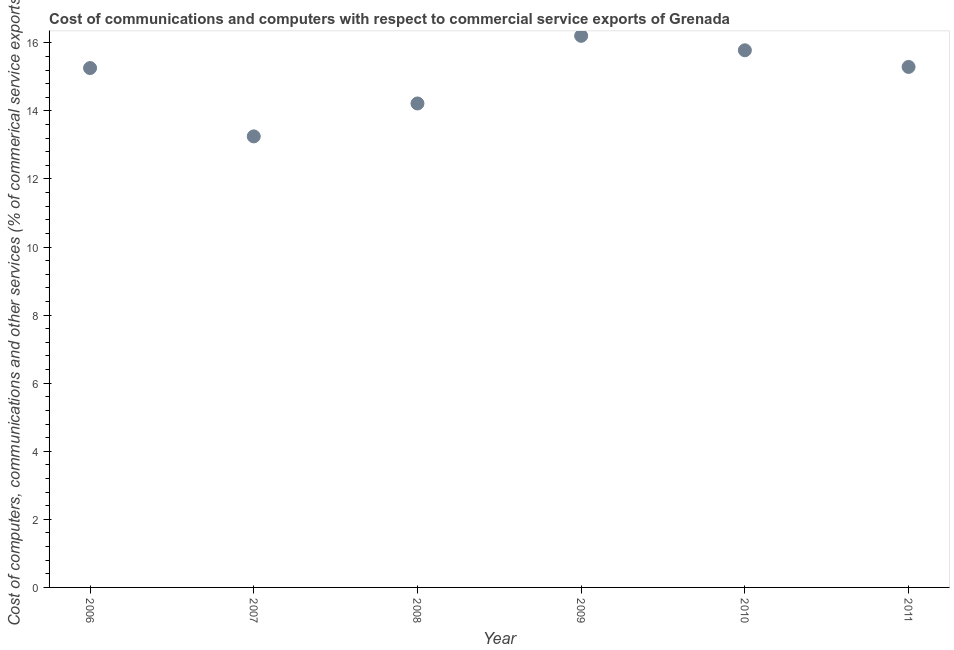What is the  computer and other services in 2006?
Ensure brevity in your answer.  15.26. Across all years, what is the maximum cost of communications?
Give a very brief answer. 16.2. Across all years, what is the minimum cost of communications?
Keep it short and to the point. 13.25. What is the sum of the  computer and other services?
Provide a succinct answer. 90. What is the difference between the  computer and other services in 2007 and 2008?
Ensure brevity in your answer.  -0.97. What is the average cost of communications per year?
Provide a succinct answer. 15. What is the median  computer and other services?
Give a very brief answer. 15.27. In how many years, is the cost of communications greater than 8.8 %?
Offer a very short reply. 6. Do a majority of the years between 2007 and 2011 (inclusive) have cost of communications greater than 10.8 %?
Ensure brevity in your answer.  Yes. What is the ratio of the  computer and other services in 2006 to that in 2009?
Offer a very short reply. 0.94. Is the cost of communications in 2006 less than that in 2009?
Your answer should be very brief. Yes. Is the difference between the cost of communications in 2009 and 2010 greater than the difference between any two years?
Make the answer very short. No. What is the difference between the highest and the second highest cost of communications?
Your response must be concise. 0.42. What is the difference between the highest and the lowest cost of communications?
Make the answer very short. 2.95. Does the  computer and other services monotonically increase over the years?
Your response must be concise. No. How many dotlines are there?
Offer a very short reply. 1. What is the difference between two consecutive major ticks on the Y-axis?
Offer a terse response. 2. Are the values on the major ticks of Y-axis written in scientific E-notation?
Provide a succinct answer. No. Does the graph contain any zero values?
Ensure brevity in your answer.  No. What is the title of the graph?
Your response must be concise. Cost of communications and computers with respect to commercial service exports of Grenada. What is the label or title of the Y-axis?
Your answer should be very brief. Cost of computers, communications and other services (% of commerical service exports). What is the Cost of computers, communications and other services (% of commerical service exports) in 2006?
Your answer should be very brief. 15.26. What is the Cost of computers, communications and other services (% of commerical service exports) in 2007?
Offer a very short reply. 13.25. What is the Cost of computers, communications and other services (% of commerical service exports) in 2008?
Make the answer very short. 14.22. What is the Cost of computers, communications and other services (% of commerical service exports) in 2009?
Give a very brief answer. 16.2. What is the Cost of computers, communications and other services (% of commerical service exports) in 2010?
Your answer should be very brief. 15.78. What is the Cost of computers, communications and other services (% of commerical service exports) in 2011?
Ensure brevity in your answer.  15.29. What is the difference between the Cost of computers, communications and other services (% of commerical service exports) in 2006 and 2007?
Provide a short and direct response. 2.01. What is the difference between the Cost of computers, communications and other services (% of commerical service exports) in 2006 and 2008?
Your answer should be compact. 1.04. What is the difference between the Cost of computers, communications and other services (% of commerical service exports) in 2006 and 2009?
Keep it short and to the point. -0.95. What is the difference between the Cost of computers, communications and other services (% of commerical service exports) in 2006 and 2010?
Provide a succinct answer. -0.52. What is the difference between the Cost of computers, communications and other services (% of commerical service exports) in 2006 and 2011?
Give a very brief answer. -0.03. What is the difference between the Cost of computers, communications and other services (% of commerical service exports) in 2007 and 2008?
Keep it short and to the point. -0.97. What is the difference between the Cost of computers, communications and other services (% of commerical service exports) in 2007 and 2009?
Keep it short and to the point. -2.95. What is the difference between the Cost of computers, communications and other services (% of commerical service exports) in 2007 and 2010?
Your answer should be compact. -2.53. What is the difference between the Cost of computers, communications and other services (% of commerical service exports) in 2007 and 2011?
Your response must be concise. -2.04. What is the difference between the Cost of computers, communications and other services (% of commerical service exports) in 2008 and 2009?
Your answer should be very brief. -1.99. What is the difference between the Cost of computers, communications and other services (% of commerical service exports) in 2008 and 2010?
Offer a terse response. -1.56. What is the difference between the Cost of computers, communications and other services (% of commerical service exports) in 2008 and 2011?
Ensure brevity in your answer.  -1.07. What is the difference between the Cost of computers, communications and other services (% of commerical service exports) in 2009 and 2010?
Your answer should be compact. 0.42. What is the difference between the Cost of computers, communications and other services (% of commerical service exports) in 2009 and 2011?
Give a very brief answer. 0.91. What is the difference between the Cost of computers, communications and other services (% of commerical service exports) in 2010 and 2011?
Provide a short and direct response. 0.49. What is the ratio of the Cost of computers, communications and other services (% of commerical service exports) in 2006 to that in 2007?
Your response must be concise. 1.15. What is the ratio of the Cost of computers, communications and other services (% of commerical service exports) in 2006 to that in 2008?
Your answer should be compact. 1.07. What is the ratio of the Cost of computers, communications and other services (% of commerical service exports) in 2006 to that in 2009?
Your answer should be compact. 0.94. What is the ratio of the Cost of computers, communications and other services (% of commerical service exports) in 2006 to that in 2010?
Provide a short and direct response. 0.97. What is the ratio of the Cost of computers, communications and other services (% of commerical service exports) in 2007 to that in 2008?
Offer a terse response. 0.93. What is the ratio of the Cost of computers, communications and other services (% of commerical service exports) in 2007 to that in 2009?
Provide a short and direct response. 0.82. What is the ratio of the Cost of computers, communications and other services (% of commerical service exports) in 2007 to that in 2010?
Your response must be concise. 0.84. What is the ratio of the Cost of computers, communications and other services (% of commerical service exports) in 2007 to that in 2011?
Provide a succinct answer. 0.87. What is the ratio of the Cost of computers, communications and other services (% of commerical service exports) in 2008 to that in 2009?
Your answer should be very brief. 0.88. What is the ratio of the Cost of computers, communications and other services (% of commerical service exports) in 2008 to that in 2010?
Give a very brief answer. 0.9. What is the ratio of the Cost of computers, communications and other services (% of commerical service exports) in 2009 to that in 2011?
Make the answer very short. 1.06. What is the ratio of the Cost of computers, communications and other services (% of commerical service exports) in 2010 to that in 2011?
Provide a succinct answer. 1.03. 